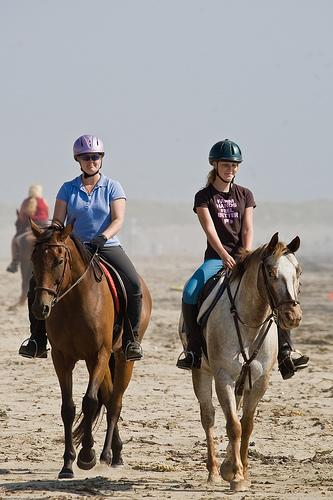Count the number of horses in the image and give a brief description of their appearances. There are two horses - one white and brown, and another brown horse with a black mane. Describe the different types of shirts that the riders are wearing in the image. One rider is wearing a brown shirt with pink lettering, and another is wearing a blue shirt. Describe the apparel of the person wearing the green riding helmet. The person is wearing a brown shirt with pink letters, blue tight riding pants, and a green helmet. What types of helmets are the riders wearing and what do they look like? The riders are wearing a purple helmet with a black strap and a green helmet. Describe the horses and their color in the image. There is a white and brown horse, and a brown horse with a black mane. Mention the objects and animals that are being ridden in the image. People are riding a white and brown horse and a brown horse with a black mane. Tell me the number of people in the image and the different types of clothing that they're wearing. There are three people, with one girl wearing a brown shirt, blue pants, and a green helmet, and the other woman wearing a blue shirt, black pants, and a purple helmet. Explain the scene where three people are riding the horses. Three people are riding horses on a sandy ground, wearing riding attire, and helmets for safety. How many helmets are in the image, and list their colors. There are two helmets, one purple and one green. Identify the primary activity happening in the image. Three people are riding horses on sandy ground. 